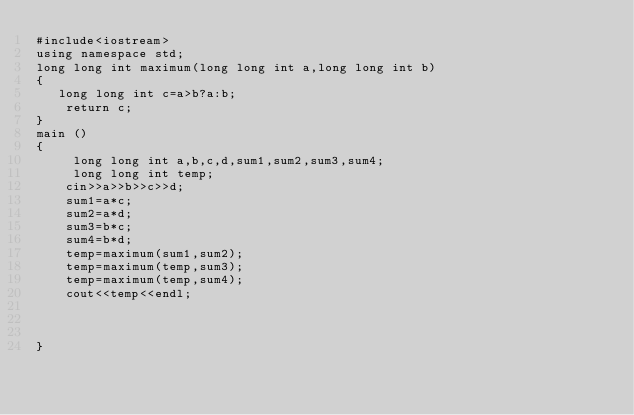<code> <loc_0><loc_0><loc_500><loc_500><_C++_>#include<iostream>
using namespace std;
long long int maximum(long long int a,long long int b)
{
   long long int c=a>b?a:b;
    return c;
}
main ()
{
     long long int a,b,c,d,sum1,sum2,sum3,sum4;
     long long int temp;
    cin>>a>>b>>c>>d;
    sum1=a*c;
    sum2=a*d;
    sum3=b*c;
    sum4=b*d;
    temp=maximum(sum1,sum2);
    temp=maximum(temp,sum3);
    temp=maximum(temp,sum4);
    cout<<temp<<endl;



}
</code> 